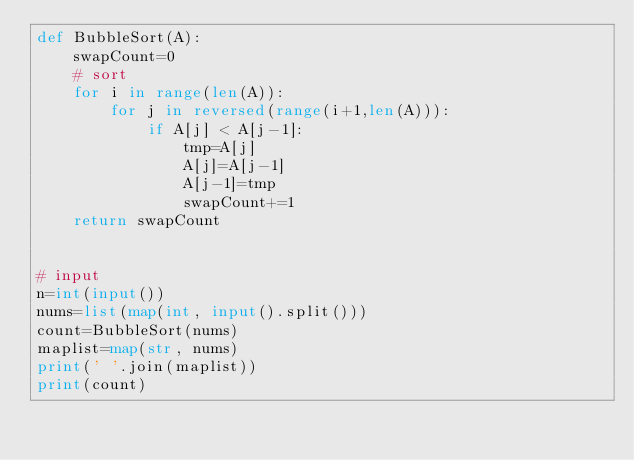<code> <loc_0><loc_0><loc_500><loc_500><_Python_>def BubbleSort(A):
    swapCount=0
    # sort
    for i in range(len(A)):
        for j in reversed(range(i+1,len(A))):
            if A[j] < A[j-1]:
                tmp=A[j]
                A[j]=A[j-1]
                A[j-1]=tmp
                swapCount+=1
    return swapCount
    

# input
n=int(input())
nums=list(map(int, input().split()))
count=BubbleSort(nums)
maplist=map(str, nums)
print(' '.join(maplist))
print(count)
</code> 